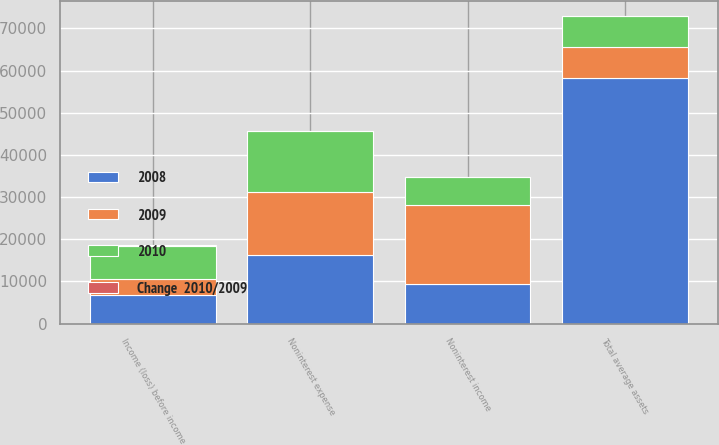Convert chart. <chart><loc_0><loc_0><loc_500><loc_500><stacked_bar_chart><ecel><fcel>Noninterest income<fcel>Noninterest expense<fcel>Income (loss) before income<fcel>Total average assets<nl><fcel>2009<fcel>18778<fcel>15063<fcel>3715<fcel>7393<nl><fcel>2010<fcel>6521<fcel>14487<fcel>7982<fcel>7393<nl><fcel>Change  2010/2009<fcel>188<fcel>4<fcel>146.5<fcel>20.6<nl><fcel>2008<fcel>9360<fcel>16206<fcel>6804<fcel>58145<nl></chart> 